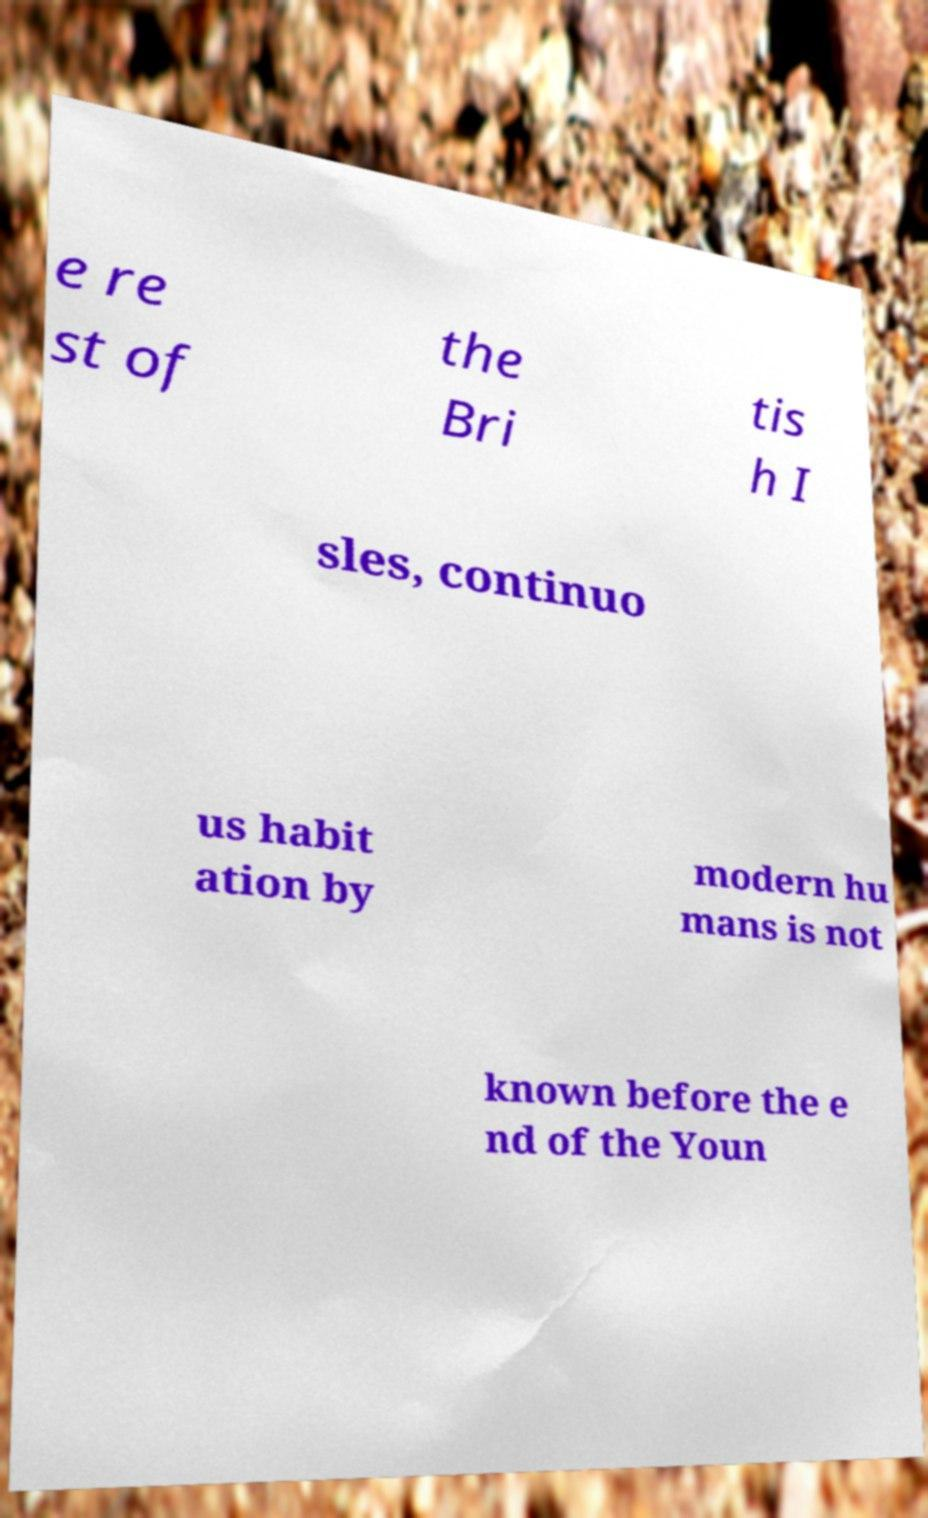Please read and relay the text visible in this image. What does it say? e re st of the Bri tis h I sles, continuo us habit ation by modern hu mans is not known before the e nd of the Youn 